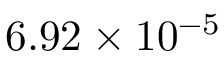<formula> <loc_0><loc_0><loc_500><loc_500>6 . 9 2 \times 1 0 ^ { - 5 }</formula> 